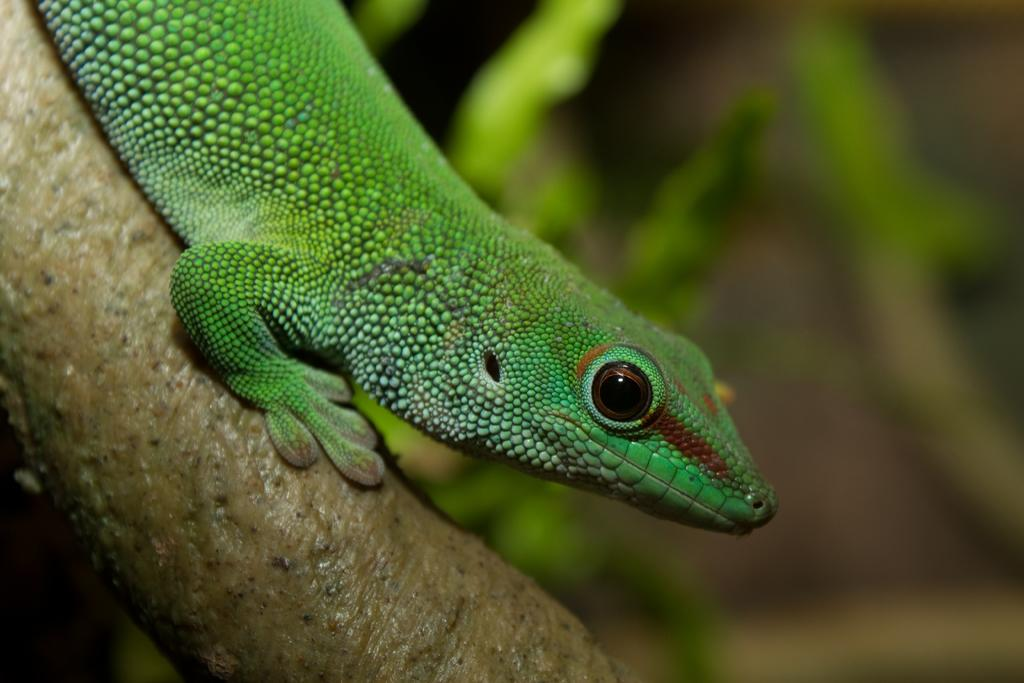What type of animal is in the image? There is a reptile in the image. Where is the reptile located? The reptile is on a branch. What can be seen in the background of the image? There are leaves visible in the background of the image. How would you describe the background of the image? The background appears blurry. What type of fuel is the reptile using to climb the branch in the image? The reptile is not using any fuel to climb the branch in the image; it is simply resting on the branch. 